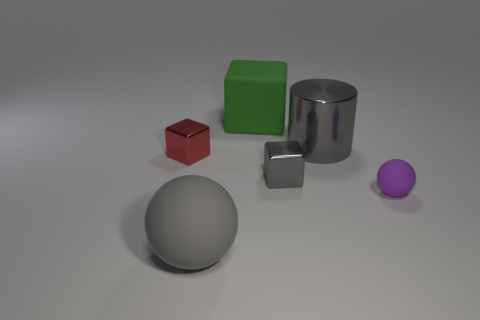Subtract all cyan spheres. Subtract all red blocks. How many spheres are left? 2 Add 2 cyan matte things. How many objects exist? 8 Subtract all spheres. How many objects are left? 4 Add 6 gray cylinders. How many gray cylinders exist? 7 Subtract 0 cyan cylinders. How many objects are left? 6 Subtract all tiny red metallic balls. Subtract all big gray matte spheres. How many objects are left? 5 Add 2 green things. How many green things are left? 3 